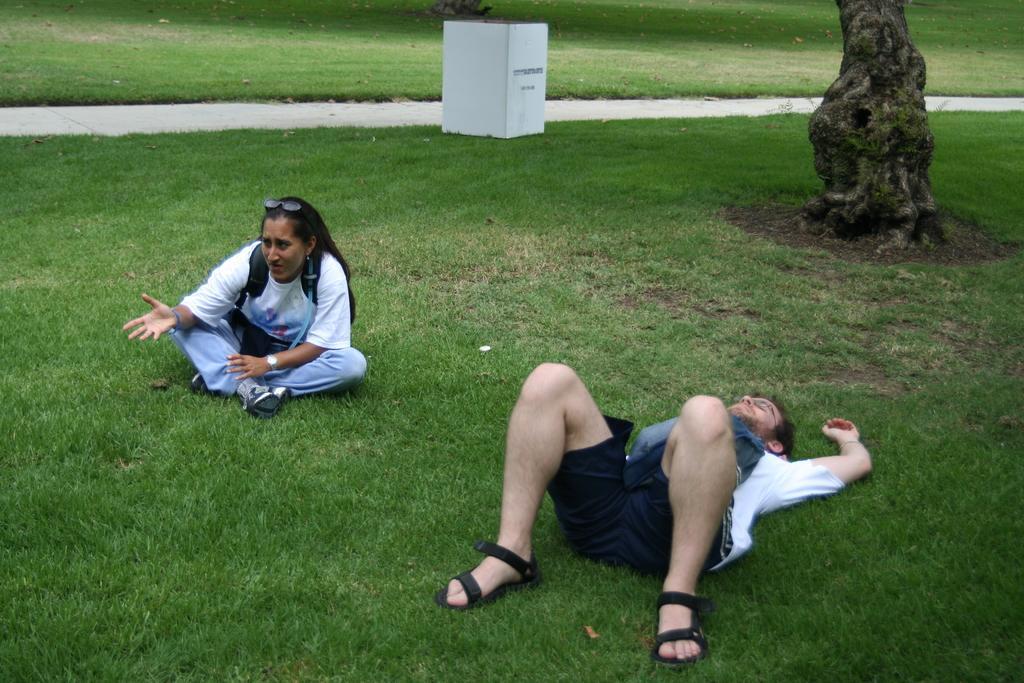Could you give a brief overview of what you see in this image? In this picture we can see a man lying on the ground and beside him a woman sitting, goggles, watch, tree trunk, box, path and in the background we can see the grass. 